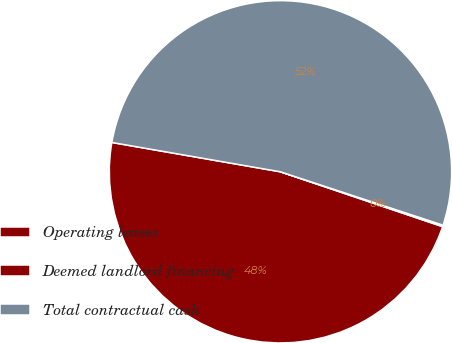<chart> <loc_0><loc_0><loc_500><loc_500><pie_chart><fcel>Operating leases<fcel>Deemed landlord financing<fcel>Total contractual cash<nl><fcel>47.55%<fcel>0.14%<fcel>52.31%<nl></chart> 